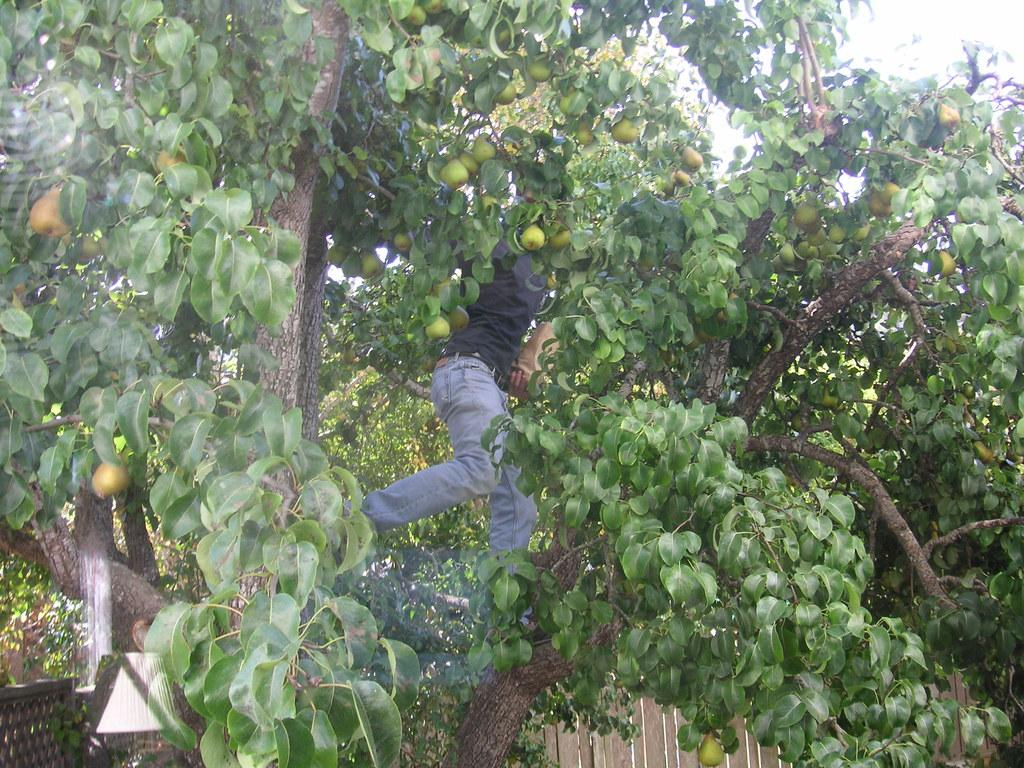What type of plant is visible in the image? There is a tree with fruits and leaves in the image. Is there anyone interacting with the tree in the image? Yes, there is a person on the tree. What can be seen in the background of the image? There is wooden fencing. What type of attraction is visible in the image? There is no attraction present in the image; it features a tree with fruits and leaves and a person on the tree. Which direction is the tree facing in the image? The provided facts do not indicate the direction the tree is facing, so it cannot be determined from the image. 